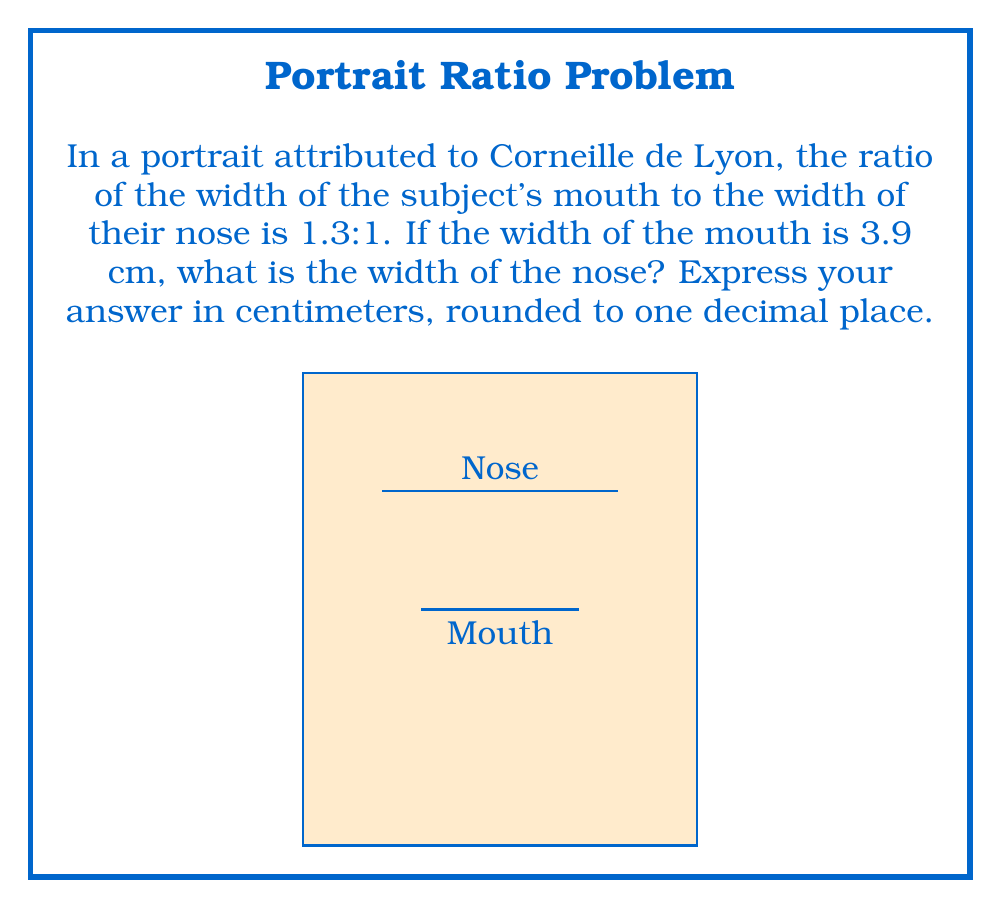Can you answer this question? Let's approach this step-by-step:

1) We are given that the ratio of mouth width to nose width is 1.3:1.
   This can be expressed mathematically as:
   
   $$\frac{\text{Mouth width}}{\text{Nose width}} = \frac{1.3}{1}$$

2) We know the mouth width is 3.9 cm. Let's call the nose width $x$ cm.
   We can set up the equation:

   $$\frac{3.9}{x} = \frac{1.3}{1}$$

3) To solve for $x$, we can cross-multiply:

   $$3.9 \cdot 1 = 1.3x$$

4) Simplify:

   $$3.9 = 1.3x$$

5) Divide both sides by 1.3:

   $$\frac{3.9}{1.3} = x$$

6) Calculate:

   $$x = 3 \text{ cm}$$

7) The question asks for the answer rounded to one decimal place, but 3 cm is already in that form.

Thus, the width of the nose in the portrait is 3.0 cm.
Answer: 3.0 cm 